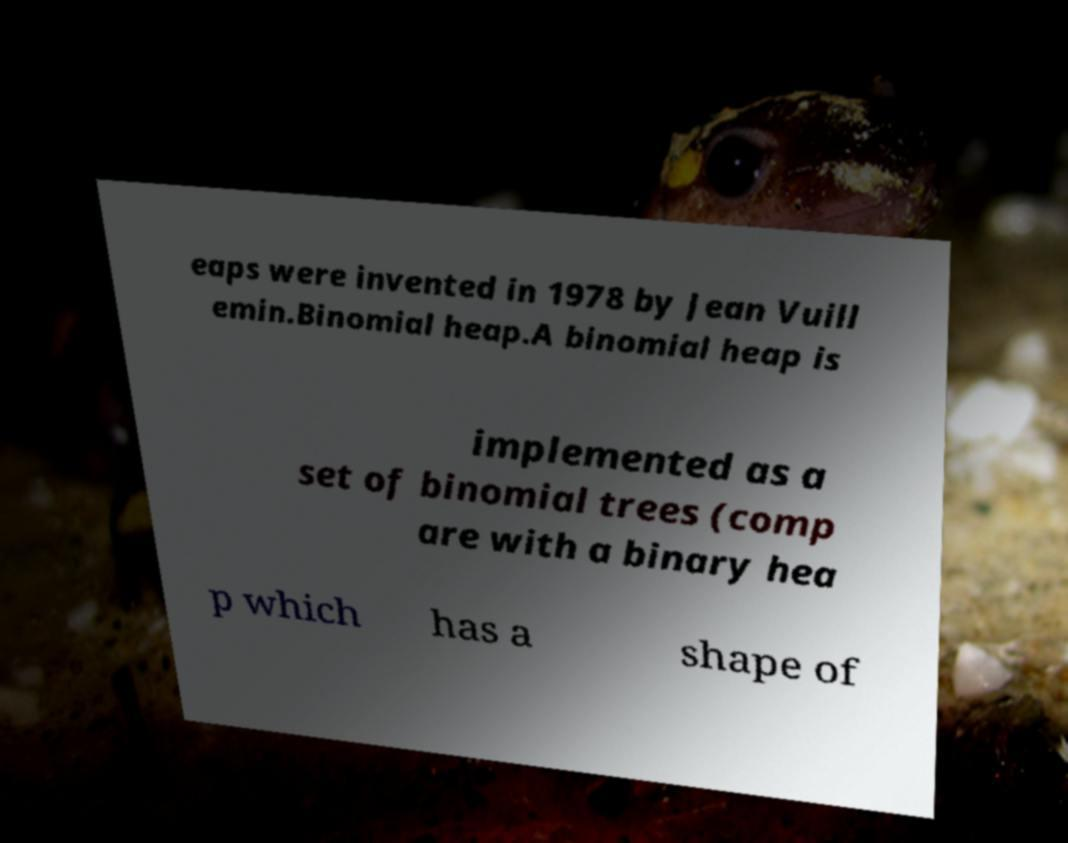Please read and relay the text visible in this image. What does it say? eaps were invented in 1978 by Jean Vuill emin.Binomial heap.A binomial heap is implemented as a set of binomial trees (comp are with a binary hea p which has a shape of 